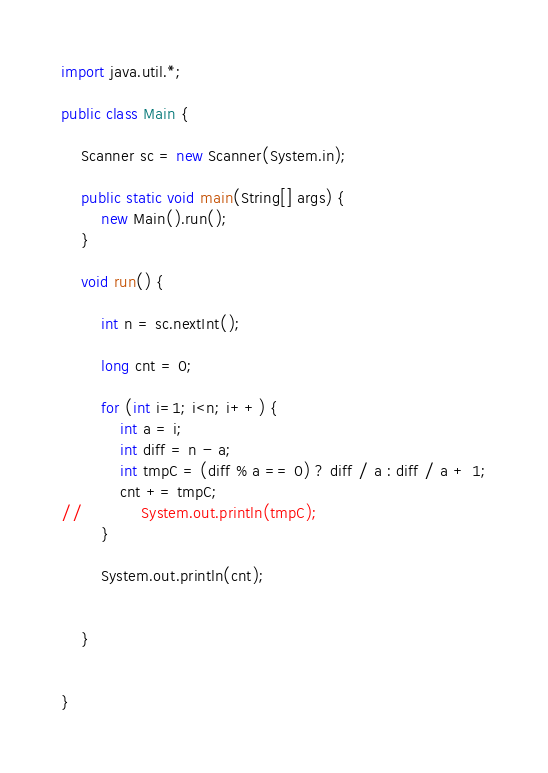Convert code to text. <code><loc_0><loc_0><loc_500><loc_500><_Java_>import java.util.*;

public class Main {

    Scanner sc = new Scanner(System.in);

    public static void main(String[] args) {
        new Main().run();
    }

    void run() {

        int n = sc.nextInt();

        long cnt = 0;

        for (int i=1; i<n; i++) {
            int a = i;
            int diff = n - a;
            int tmpC = (diff % a == 0) ? diff / a : diff / a + 1;
            cnt += tmpC;
//            System.out.println(tmpC);
        }

        System.out.println(cnt);


    }


}

</code> 